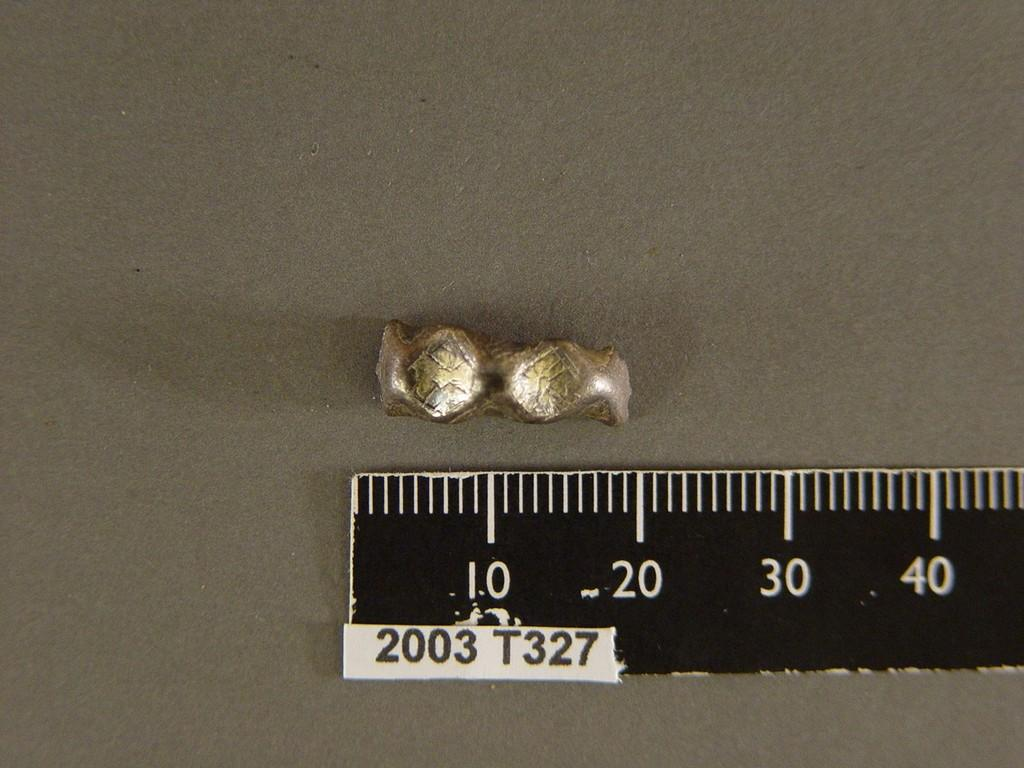<image>
Summarize the visual content of the image. A ruler that says 2003 is next to a piece of metal that goes to the 20 line. 